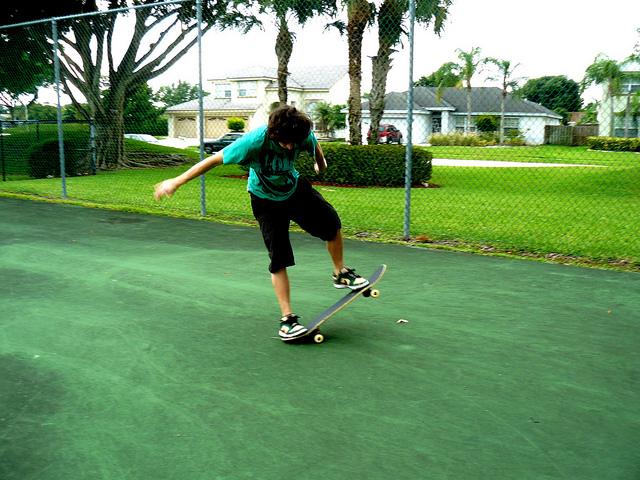How many people are in this photo?
Write a very short answer. 1. Is this person wearing shorts?
Concise answer only. Yes. What sport is this?
Answer briefly. Skateboarding. What is the surface being skated on?
Quick response, please. Tennis court. 